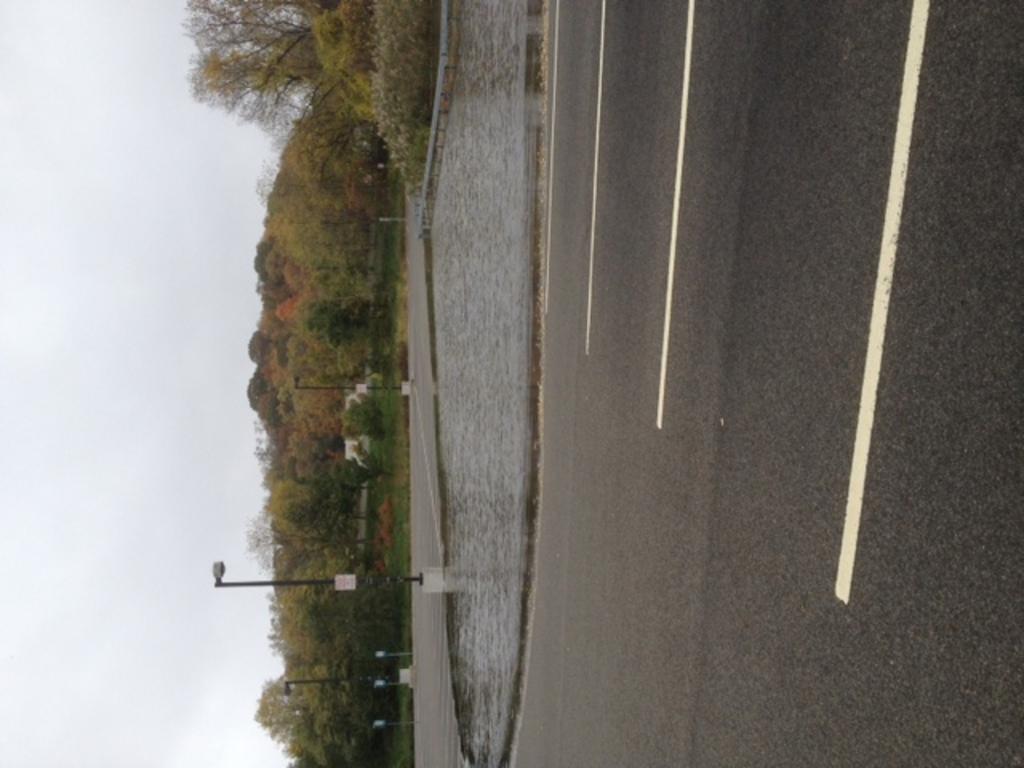Can you describe this image briefly? On the right side there is a road. Near to the road there is water. Also there are light poles. On the left side there are trees and sky. 